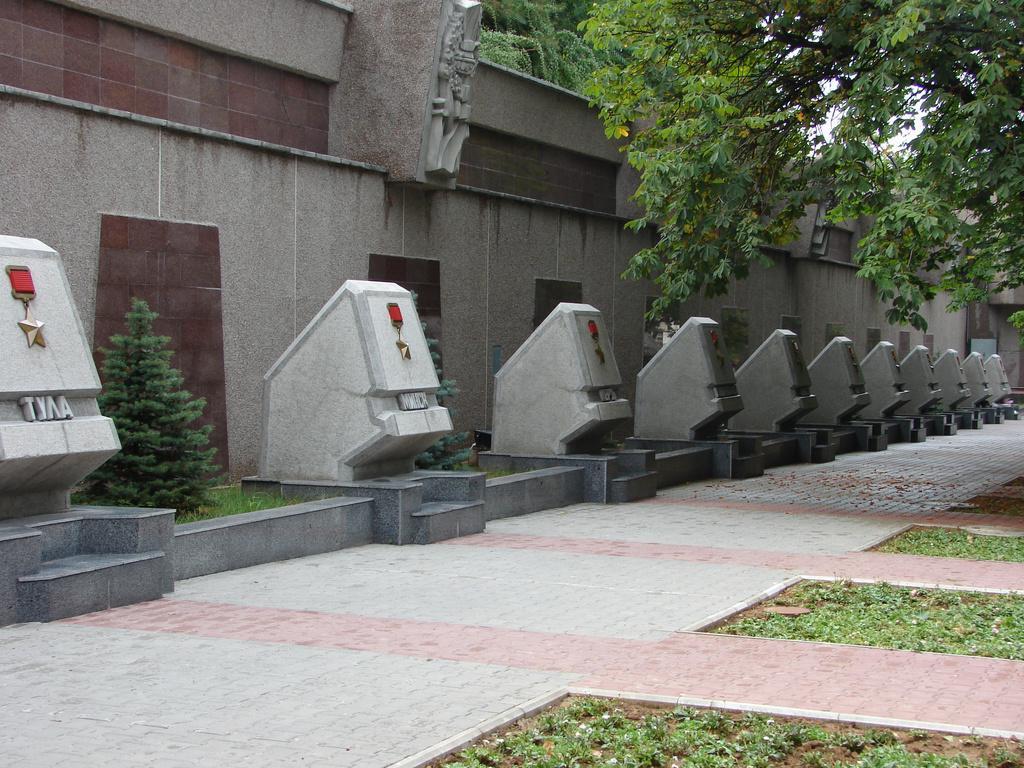How would you summarize this image in a sentence or two? In this image, we can see trees, stones and in the background, there is wall. 